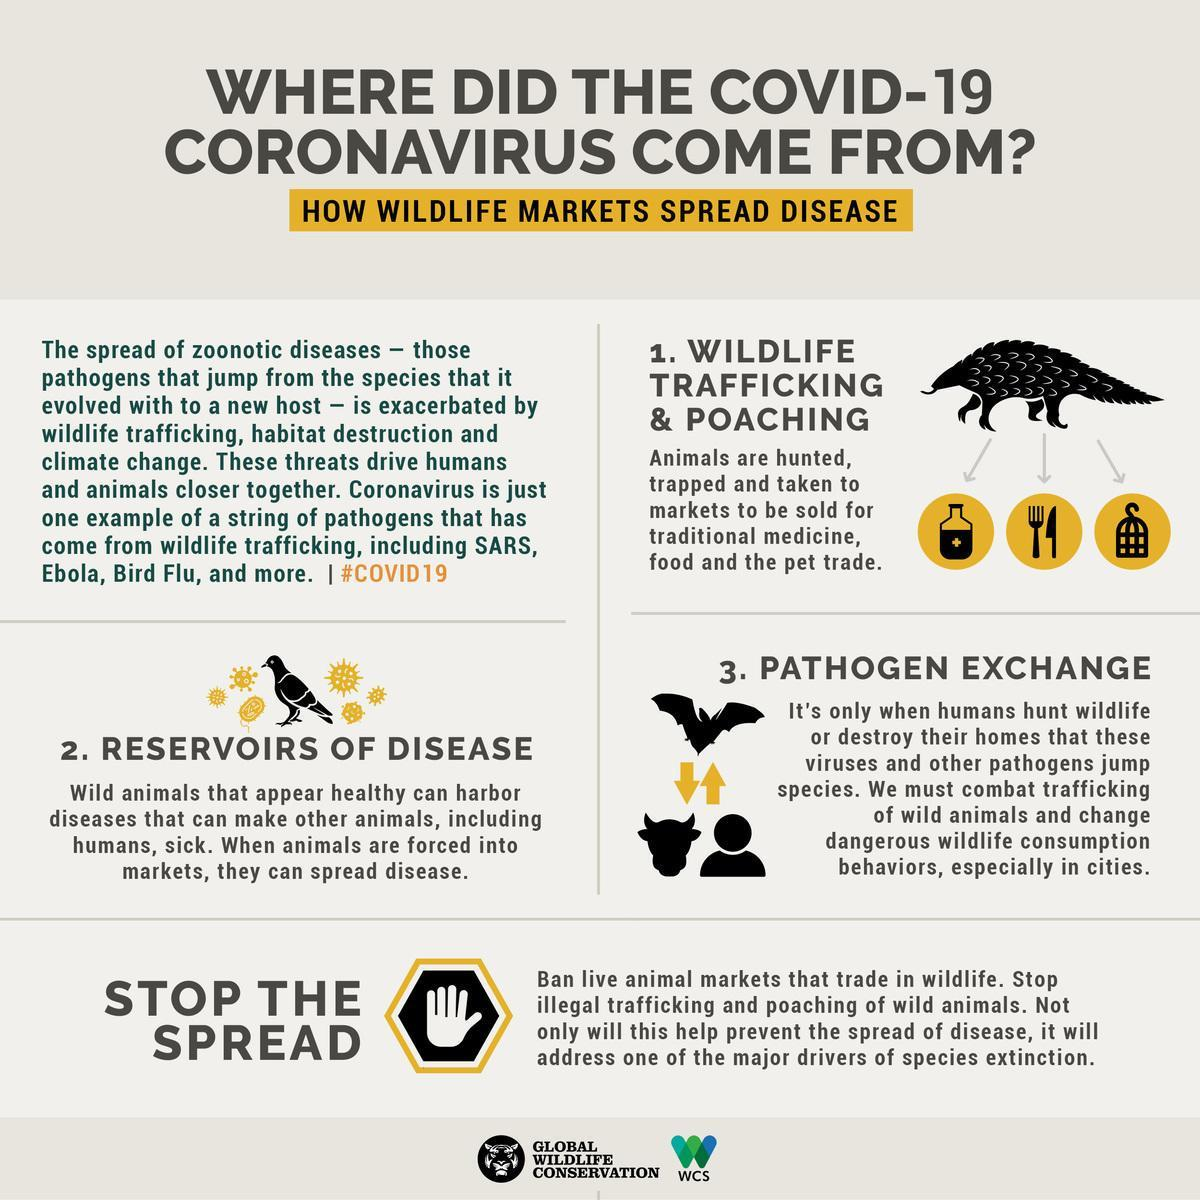How many animals are in this infographic?
Answer the question with a short phrase. 2 How many birds are in this infographic? 2 